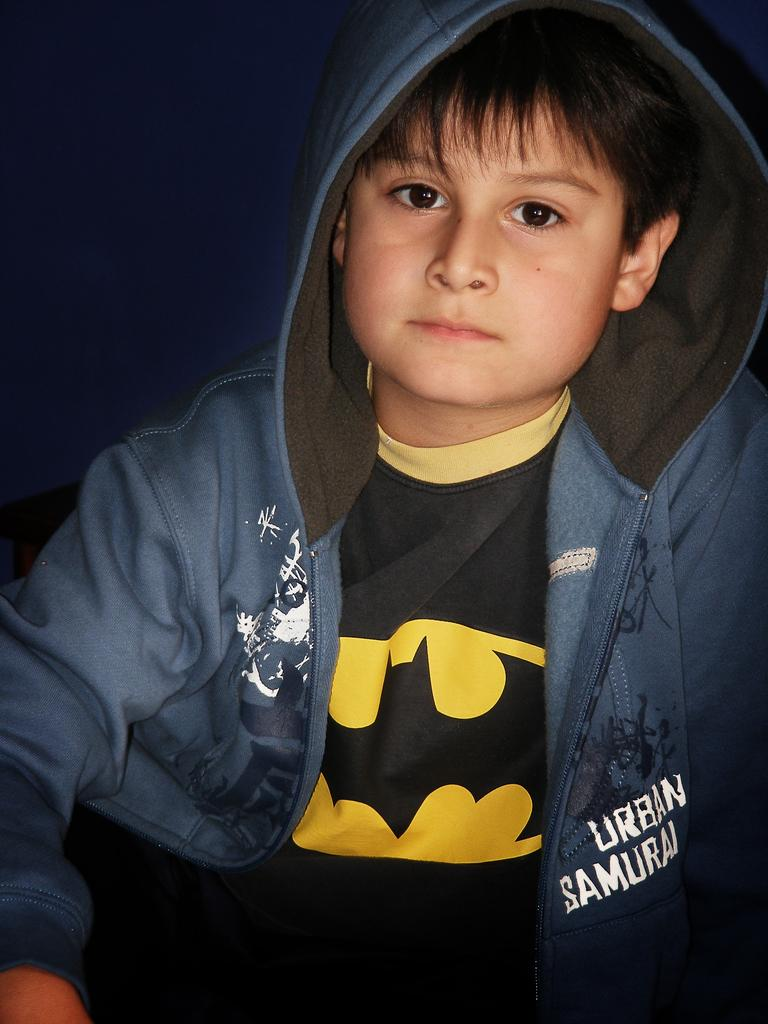What is the main subject of the image? There is a boy in the image. What can be observed about the background of the image? The background of the image is dark. Can you see any fog in the image? There is no mention of fog in the image, so it cannot be determined if it is present or not. 